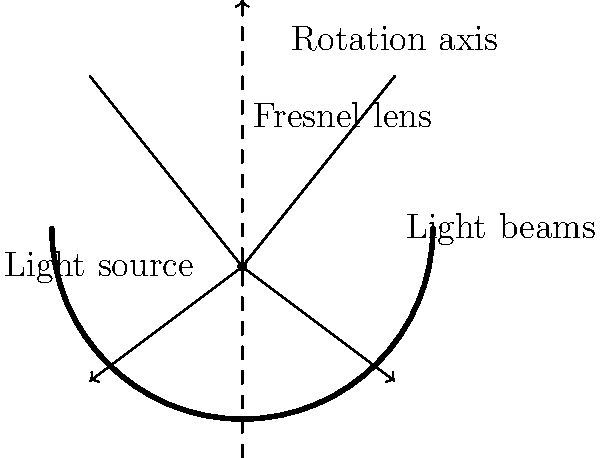In the cross-sectional diagram of a rotating Fresnel lens system, what is the primary physical principle that allows the lens to concentrate light into a powerful beam, and how does the rotation of the lens affect its function in a lighthouse? To understand the mechanics of a rotating Fresnel lens, let's break it down step-by-step:

1. Fresnel lens design:
   The Fresnel lens is a special type of lens that consists of a series of concentric, prism-like rings. This design allows for a large aperture and short focal length without the mass and volume of material that would be required by a conventional lens.

2. Light concentration:
   The primary physical principle at work is refraction. Each ring of the Fresnel lens is precisely angled to bend light rays from the source towards a common focal point. This creates a concentrated, parallel beam of light.

3. Magnification of light:
   The Fresnel lens effectively magnifies the light source. The equation for magnification is:

   $$M = \frac{h_i}{h_o} = -\frac{d_i}{d_o}$$

   Where $M$ is magnification, $h_i$ and $h_o$ are image and object heights, and $d_i$ and $d_o$ are image and object distances from the lens.

4. Rotation mechanism:
   The lens is mounted on a rotating platform. The angular velocity $\omega$ of the rotation is given by:

   $$\omega = \frac{2\pi}{T}$$

   Where $T$ is the period of rotation.

5. Effect of rotation:
   As the lens rotates, the concentrated beam of light sweeps across the horizon. This creates the characteristic flashing pattern of a lighthouse. The time between flashes is directly related to the rotational speed of the lens.

6. Range and visibility:
   The intensity of light $I$ at a distance $r$ from a source of luminous intensity $I_0$ follows the inverse square law:

   $$I = \frac{I_0}{r^2}$$

   The Fresnel lens' ability to concentrate light allows the lighthouse to be visible at greater distances.
Answer: Refraction concentrates light; rotation creates flashing pattern. 